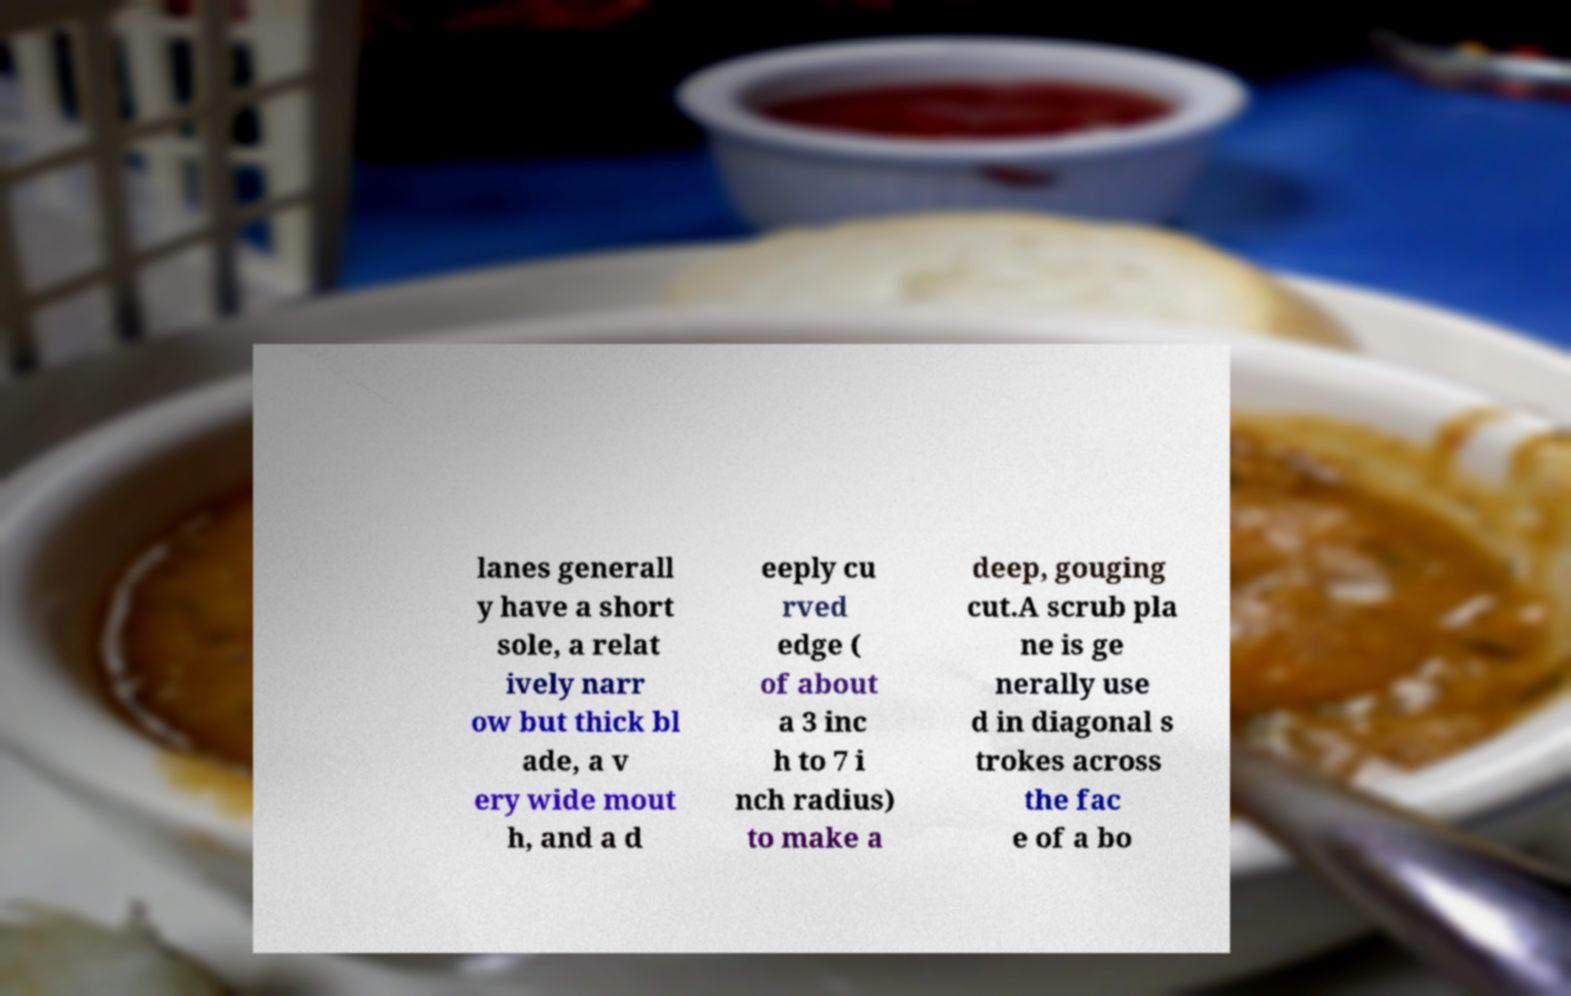For documentation purposes, I need the text within this image transcribed. Could you provide that? lanes generall y have a short sole, a relat ively narr ow but thick bl ade, a v ery wide mout h, and a d eeply cu rved edge ( of about a 3 inc h to 7 i nch radius) to make a deep, gouging cut.A scrub pla ne is ge nerally use d in diagonal s trokes across the fac e of a bo 